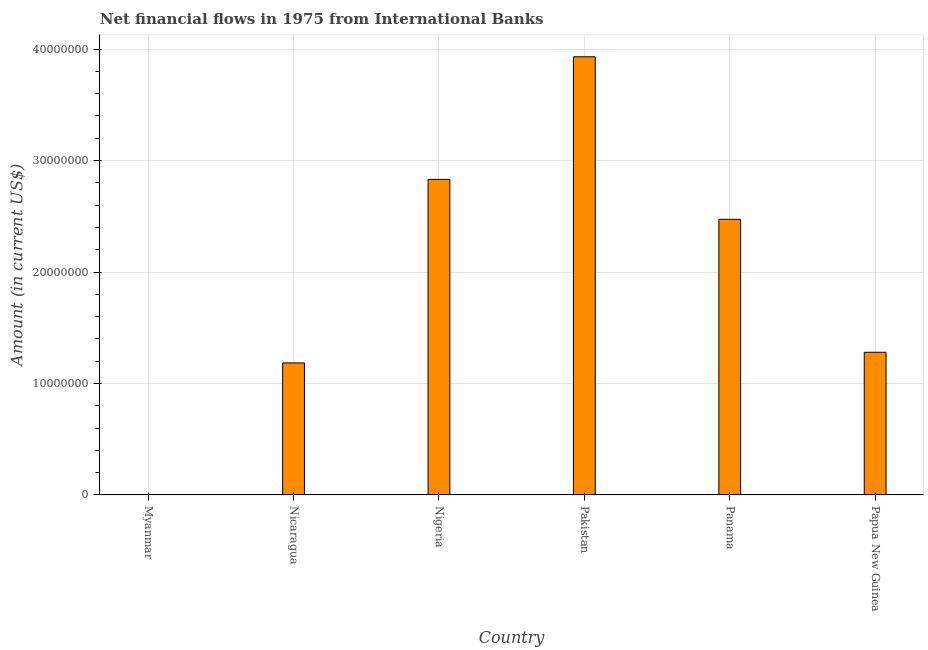Does the graph contain any zero values?
Keep it short and to the point. Yes. Does the graph contain grids?
Offer a terse response. Yes. What is the title of the graph?
Ensure brevity in your answer.  Net financial flows in 1975 from International Banks. What is the label or title of the Y-axis?
Give a very brief answer. Amount (in current US$). What is the net financial flows from ibrd in Papua New Guinea?
Your answer should be compact. 1.28e+07. Across all countries, what is the maximum net financial flows from ibrd?
Your response must be concise. 3.93e+07. Across all countries, what is the minimum net financial flows from ibrd?
Make the answer very short. 0. What is the sum of the net financial flows from ibrd?
Offer a very short reply. 1.17e+08. What is the difference between the net financial flows from ibrd in Nicaragua and Panama?
Offer a very short reply. -1.29e+07. What is the average net financial flows from ibrd per country?
Your answer should be very brief. 1.95e+07. What is the median net financial flows from ibrd?
Your answer should be very brief. 1.88e+07. What is the ratio of the net financial flows from ibrd in Pakistan to that in Papua New Guinea?
Provide a short and direct response. 3.07. What is the difference between the highest and the second highest net financial flows from ibrd?
Ensure brevity in your answer.  1.10e+07. What is the difference between the highest and the lowest net financial flows from ibrd?
Give a very brief answer. 3.93e+07. In how many countries, is the net financial flows from ibrd greater than the average net financial flows from ibrd taken over all countries?
Offer a very short reply. 3. How many bars are there?
Offer a terse response. 5. Are all the bars in the graph horizontal?
Offer a very short reply. No. What is the difference between two consecutive major ticks on the Y-axis?
Offer a very short reply. 1.00e+07. Are the values on the major ticks of Y-axis written in scientific E-notation?
Offer a very short reply. No. What is the Amount (in current US$) of Myanmar?
Ensure brevity in your answer.  0. What is the Amount (in current US$) in Nicaragua?
Make the answer very short. 1.18e+07. What is the Amount (in current US$) of Nigeria?
Provide a succinct answer. 2.83e+07. What is the Amount (in current US$) in Pakistan?
Provide a short and direct response. 3.93e+07. What is the Amount (in current US$) in Panama?
Make the answer very short. 2.47e+07. What is the Amount (in current US$) of Papua New Guinea?
Provide a short and direct response. 1.28e+07. What is the difference between the Amount (in current US$) in Nicaragua and Nigeria?
Make the answer very short. -1.65e+07. What is the difference between the Amount (in current US$) in Nicaragua and Pakistan?
Ensure brevity in your answer.  -2.75e+07. What is the difference between the Amount (in current US$) in Nicaragua and Panama?
Your answer should be compact. -1.29e+07. What is the difference between the Amount (in current US$) in Nicaragua and Papua New Guinea?
Your response must be concise. -9.58e+05. What is the difference between the Amount (in current US$) in Nigeria and Pakistan?
Make the answer very short. -1.10e+07. What is the difference between the Amount (in current US$) in Nigeria and Panama?
Provide a succinct answer. 3.58e+06. What is the difference between the Amount (in current US$) in Nigeria and Papua New Guinea?
Give a very brief answer. 1.55e+07. What is the difference between the Amount (in current US$) in Pakistan and Panama?
Offer a terse response. 1.46e+07. What is the difference between the Amount (in current US$) in Pakistan and Papua New Guinea?
Offer a terse response. 2.65e+07. What is the difference between the Amount (in current US$) in Panama and Papua New Guinea?
Offer a very short reply. 1.19e+07. What is the ratio of the Amount (in current US$) in Nicaragua to that in Nigeria?
Your answer should be very brief. 0.42. What is the ratio of the Amount (in current US$) in Nicaragua to that in Pakistan?
Keep it short and to the point. 0.3. What is the ratio of the Amount (in current US$) in Nicaragua to that in Panama?
Offer a very short reply. 0.48. What is the ratio of the Amount (in current US$) in Nicaragua to that in Papua New Guinea?
Your response must be concise. 0.93. What is the ratio of the Amount (in current US$) in Nigeria to that in Pakistan?
Make the answer very short. 0.72. What is the ratio of the Amount (in current US$) in Nigeria to that in Panama?
Give a very brief answer. 1.15. What is the ratio of the Amount (in current US$) in Nigeria to that in Papua New Guinea?
Your answer should be very brief. 2.21. What is the ratio of the Amount (in current US$) in Pakistan to that in Panama?
Ensure brevity in your answer.  1.59. What is the ratio of the Amount (in current US$) in Pakistan to that in Papua New Guinea?
Provide a succinct answer. 3.07. What is the ratio of the Amount (in current US$) in Panama to that in Papua New Guinea?
Give a very brief answer. 1.93. 